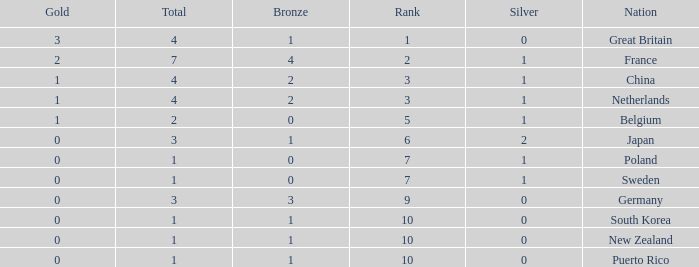What is the smallest number of gold where the total is less than 3 and the silver count is 2? None. 